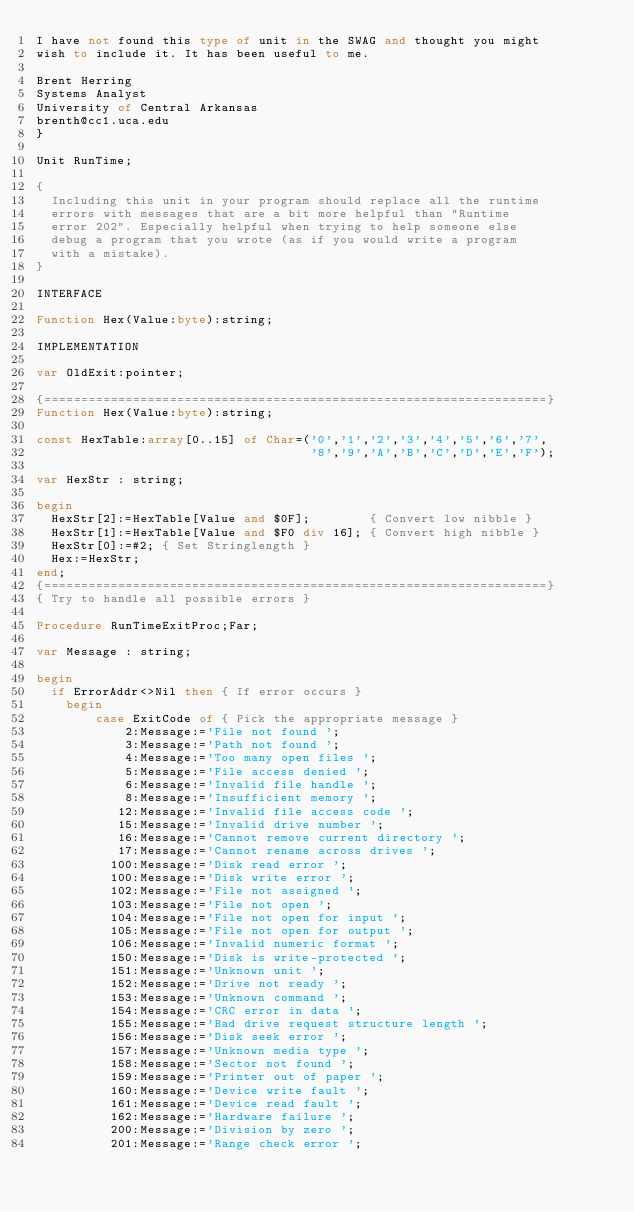<code> <loc_0><loc_0><loc_500><loc_500><_Pascal_>I have not found this type of unit in the SWAG and thought you might
wish to include it. It has been useful to me.

Brent Herring
Systems Analyst
University of Central Arkansas
brenth@cc1.uca.edu
}

Unit RunTime;

{
  Including this unit in your program should replace all the runtime
  errors with messages that are a bit more helpful than "Runtime
  error 202". Especially helpful when trying to help someone else
  debug a program that you wrote (as if you would write a program
  with a mistake).
}

INTERFACE

Function Hex(Value:byte):string;

IMPLEMENTATION

var OldExit:pointer;

{====================================================================}
Function Hex(Value:byte):string;

const HexTable:array[0..15] of Char=('0','1','2','3','4','5','6','7',
                                     '8','9','A','B','C','D','E','F');

var HexStr : string;

begin
  HexStr[2]:=HexTable[Value and $0F];        { Convert low nibble }
  HexStr[1]:=HexTable[Value and $F0 div 16]; { Convert high nibble }
  HexStr[0]:=#2; { Set Stringlength }
  Hex:=HexStr;
end;
{====================================================================}
{ Try to handle all possible errors }

Procedure RunTimeExitProc;Far;

var Message : string;

begin
  if ErrorAddr<>Nil then { If error occurs }
    begin
        case ExitCode of { Pick the appropriate message }
            2:Message:='File not found ';
            3:Message:='Path not found ';
            4:Message:='Too many open files ';
            5:Message:='File access denied ';
            6:Message:='Invalid file handle ';
            8:Message:='Insufficient memory ';
           12:Message:='Invalid file access code ';
           15:Message:='Invalid drive number ';
           16:Message:='Cannot remove current directory ';
           17:Message:='Cannot rename across drives ';
          100:Message:='Disk read error ';
          100:Message:='Disk write error ';
          102:Message:='File not assigned ';
          103:Message:='File not open ';
          104:Message:='File not open for input ';
          105:Message:='File not open for output ';
          106:Message:='Invalid numeric format ';
          150:Message:='Disk is write-protected ';
          151:Message:='Unknown unit ';
          152:Message:='Drive not ready ';
          153:Message:='Unknown command ';
          154:Message:='CRC error in data ';
          155:Message:='Bad drive request structure length ';
          156:Message:='Disk seek error ';
          157:Message:='Unknown media type ';
          158:Message:='Sector not found ';
          159:Message:='Printer out of paper ';
          160:Message:='Device write fault ';
          161:Message:='Device read fault ';
          162:Message:='Hardware failure ';
          200:Message:='Division by zero ';
          201:Message:='Range check error ';</code> 